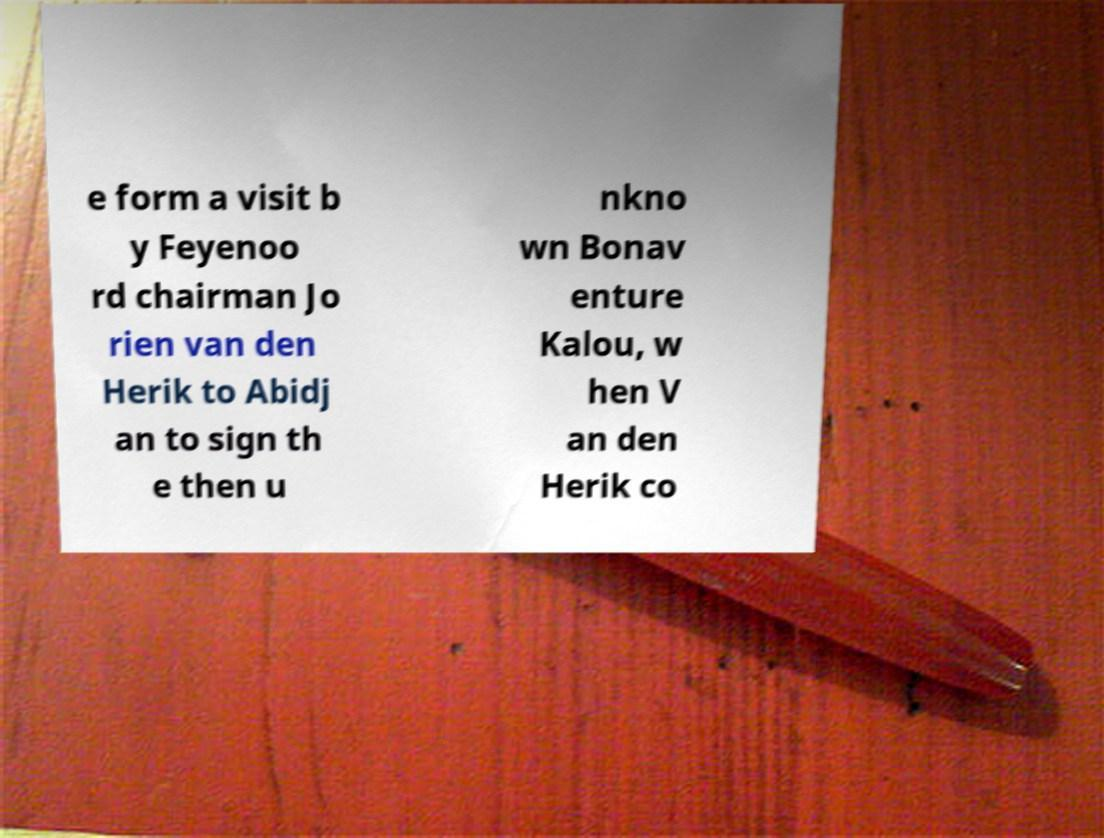Please read and relay the text visible in this image. What does it say? e form a visit b y Feyenoo rd chairman Jo rien van den Herik to Abidj an to sign th e then u nkno wn Bonav enture Kalou, w hen V an den Herik co 